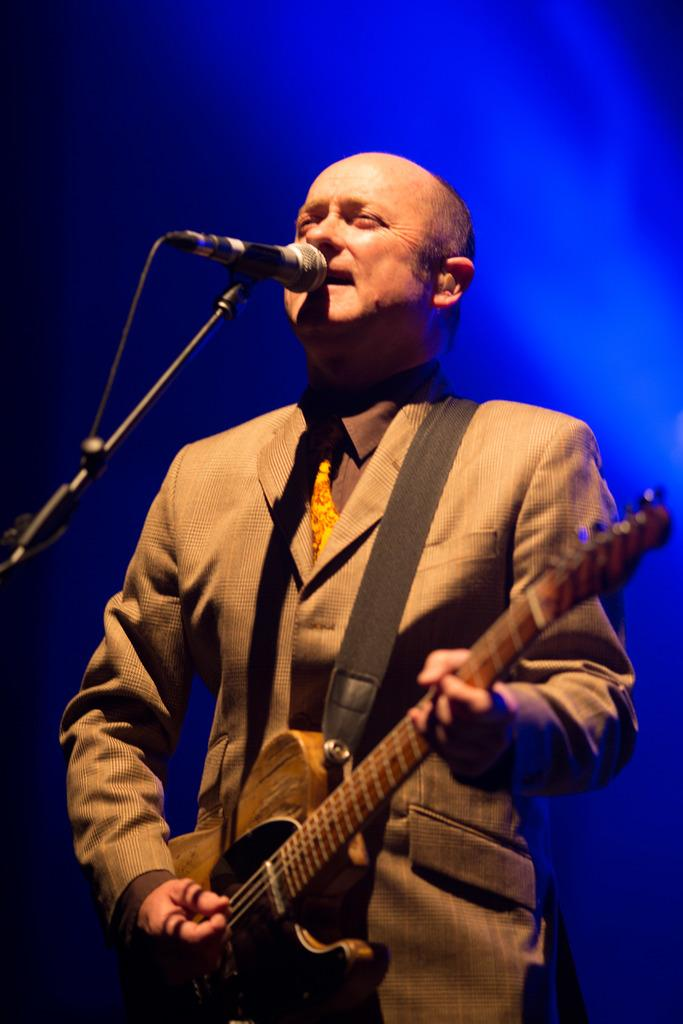What is the main subject of the image? There is a person in the image. What is the person doing in the image? The person is standing, playing a guitar, and singing. What object is present in the image that is commonly used for amplifying sound? There is a microphone in the image. What type of owl can be seen sitting on the person's shoulder in the image? There is no owl present in the image; the person is playing a guitar and singing. What is the value of the guitar in the image? The value of the guitar cannot be determined from the image alone. 